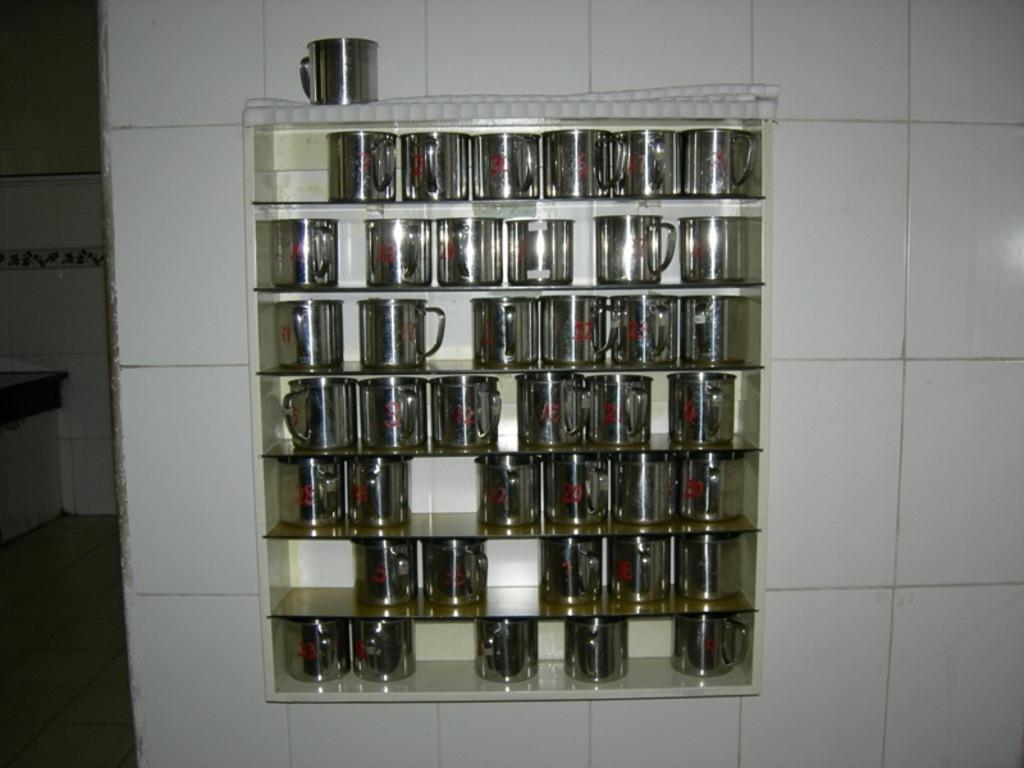What objects are visible in the image? There are cups in the image. How are the cups arranged or stored? The cups are kept in a rack. What can be seen in the background of the image? There is a wall in the background of the image. What is the color of the tiles on the wall? The wall has white-colored tiles. Can you see any celery on the sidewalk in the image? There is no sidewalk or celery present in the image. 